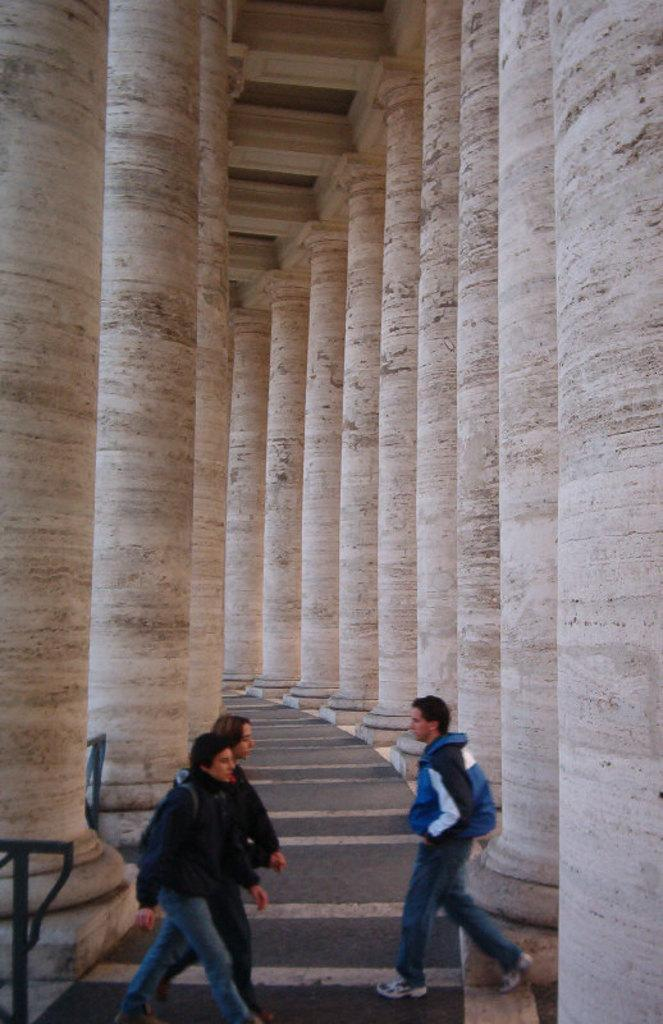How many people are in the image? There are three persons standing in the image. What are the persons made of? The persons appear to be made of iron rods. What can be seen in the background of the image? There are pillars in the background of the image. What color of paint is used on the guitar in the image? There is no guitar present in the image; the persons appear to be made of iron rods. What type of quince can be seen growing near the pillars in the image? There is no quince plant or fruit present in the image; the background features pillars. 